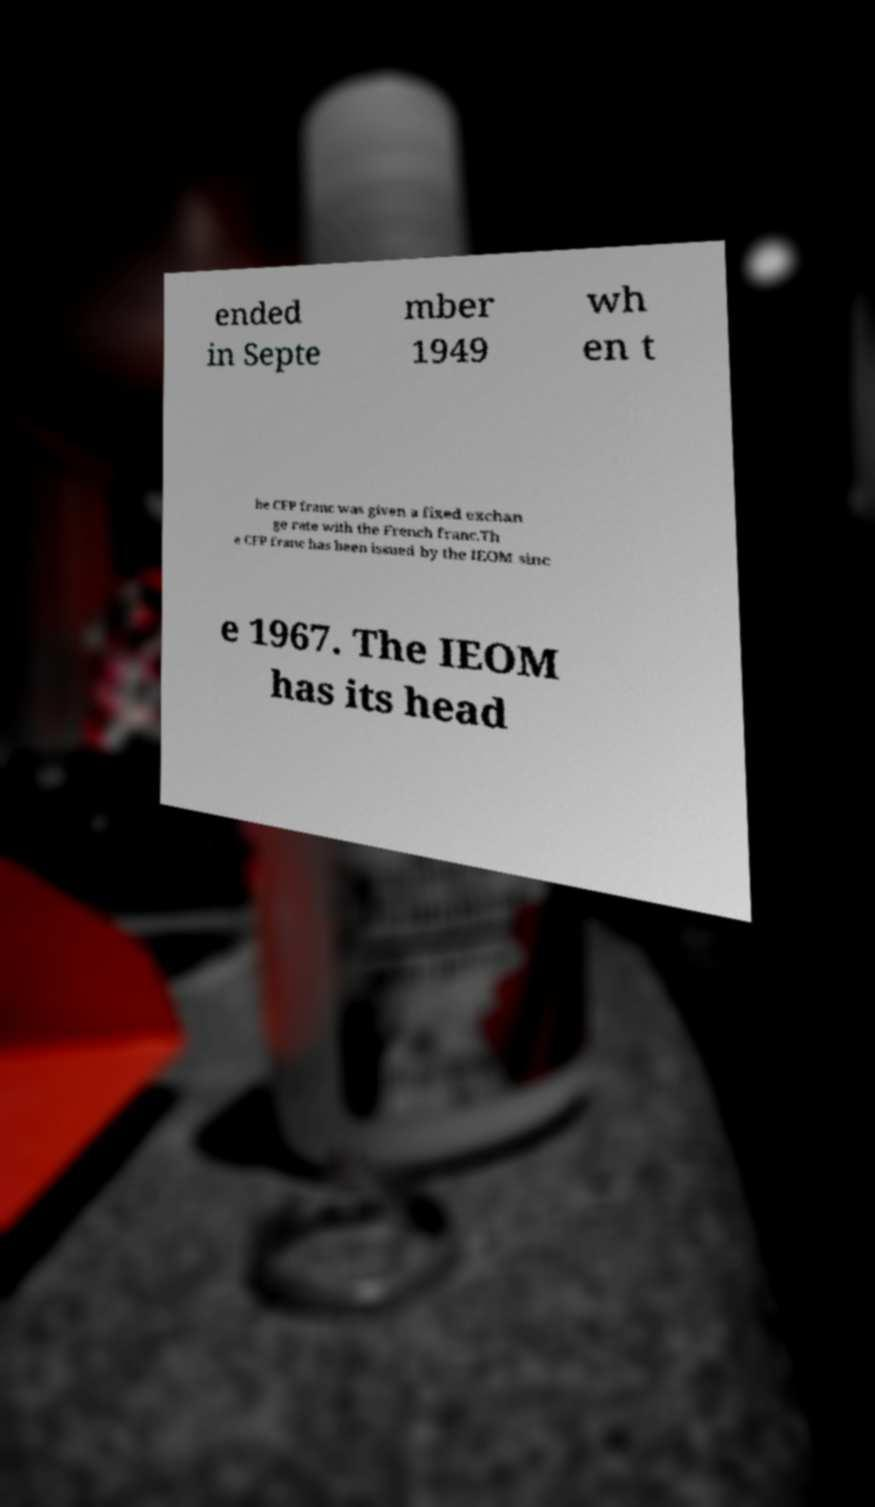Please identify and transcribe the text found in this image. ended in Septe mber 1949 wh en t he CFP franc was given a fixed exchan ge rate with the French franc.Th e CFP franc has been issued by the IEOM sinc e 1967. The IEOM has its head 